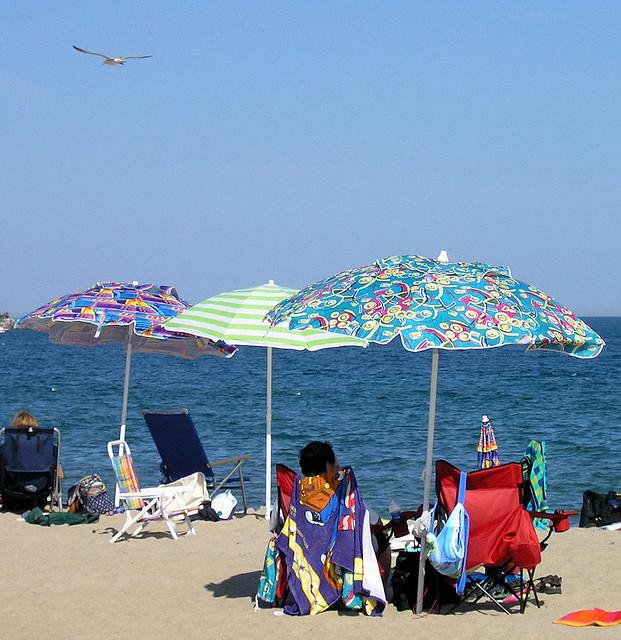What other situation might the standing items be useful for? Please explain your reasoning. rain. These umbrellas can help keep them cooler by keeping the heat off of them.  they also can keep the other elements off of them if it storms. 